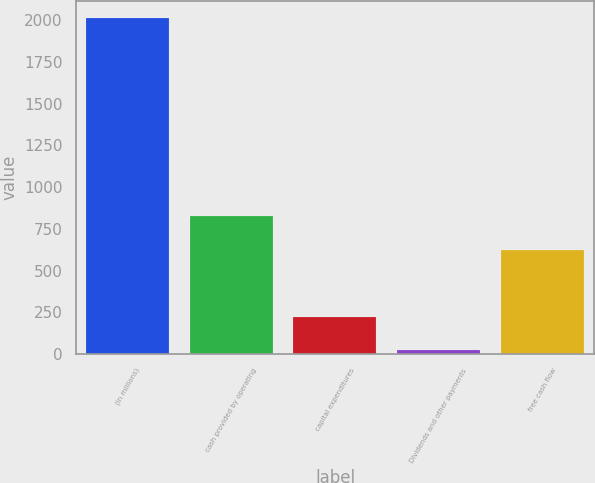Convert chart to OTSL. <chart><loc_0><loc_0><loc_500><loc_500><bar_chart><fcel>(in millions)<fcel>cash provided by operating<fcel>capital expenditures<fcel>Dividends and other payments<fcel>free cash flow<nl><fcel>2012<fcel>824.8<fcel>222.8<fcel>24<fcel>626<nl></chart> 